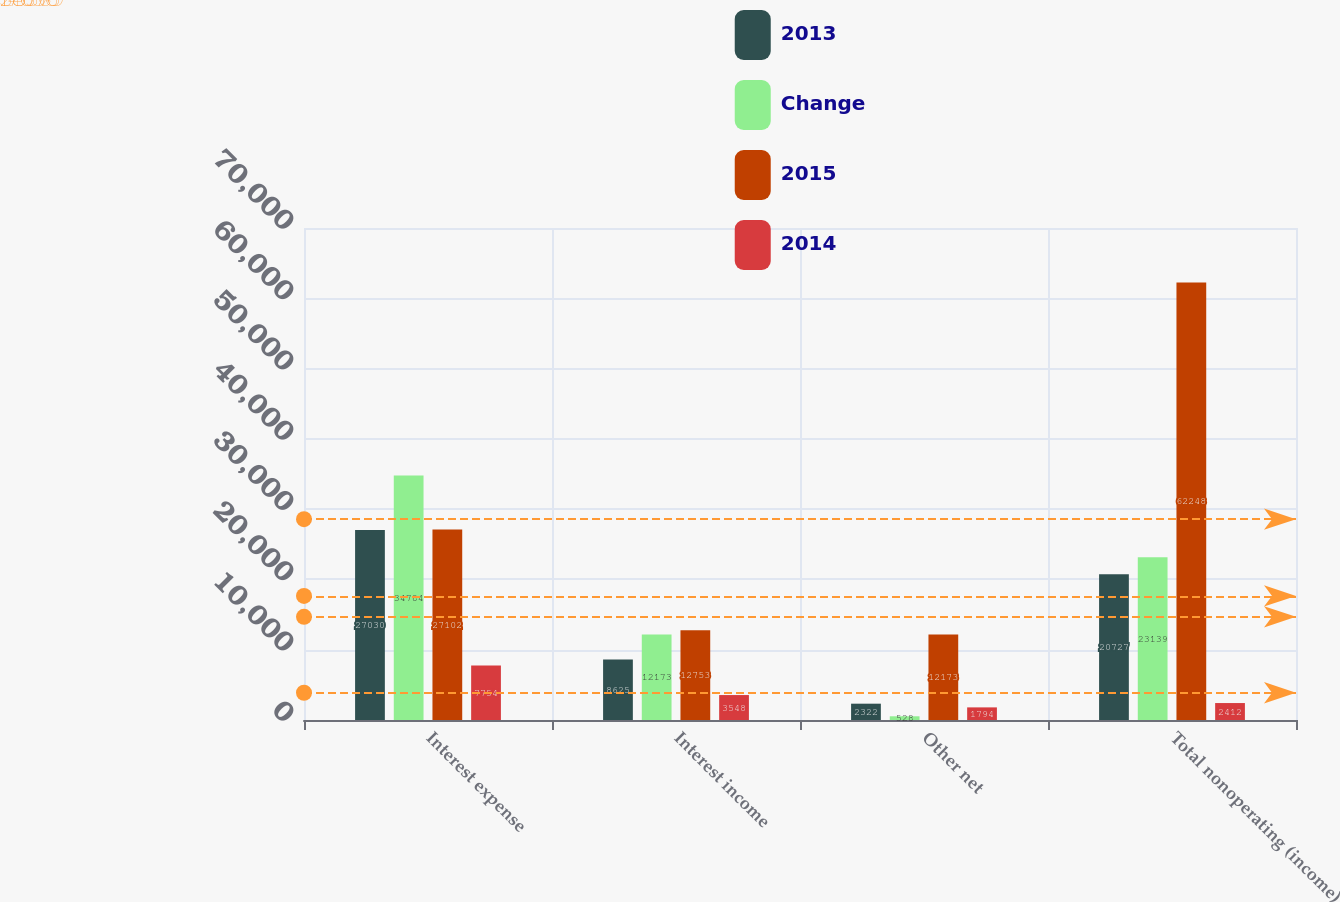Convert chart to OTSL. <chart><loc_0><loc_0><loc_500><loc_500><stacked_bar_chart><ecel><fcel>Interest expense<fcel>Interest income<fcel>Other net<fcel>Total nonoperating (income)<nl><fcel>2013<fcel>27030<fcel>8625<fcel>2322<fcel>20727<nl><fcel>Change<fcel>34784<fcel>12173<fcel>528<fcel>23139<nl><fcel>2015<fcel>27102<fcel>12753<fcel>12173<fcel>62248<nl><fcel>2014<fcel>7754<fcel>3548<fcel>1794<fcel>2412<nl></chart> 